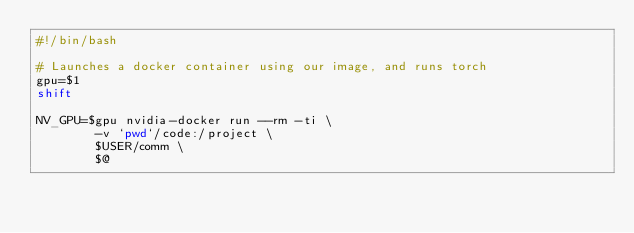<code> <loc_0><loc_0><loc_500><loc_500><_Bash_>#!/bin/bash

# Launches a docker container using our image, and runs torch
gpu=$1
shift

NV_GPU=$gpu nvidia-docker run --rm -ti \
        -v `pwd`/code:/project \
        $USER/comm \
        $@
</code> 